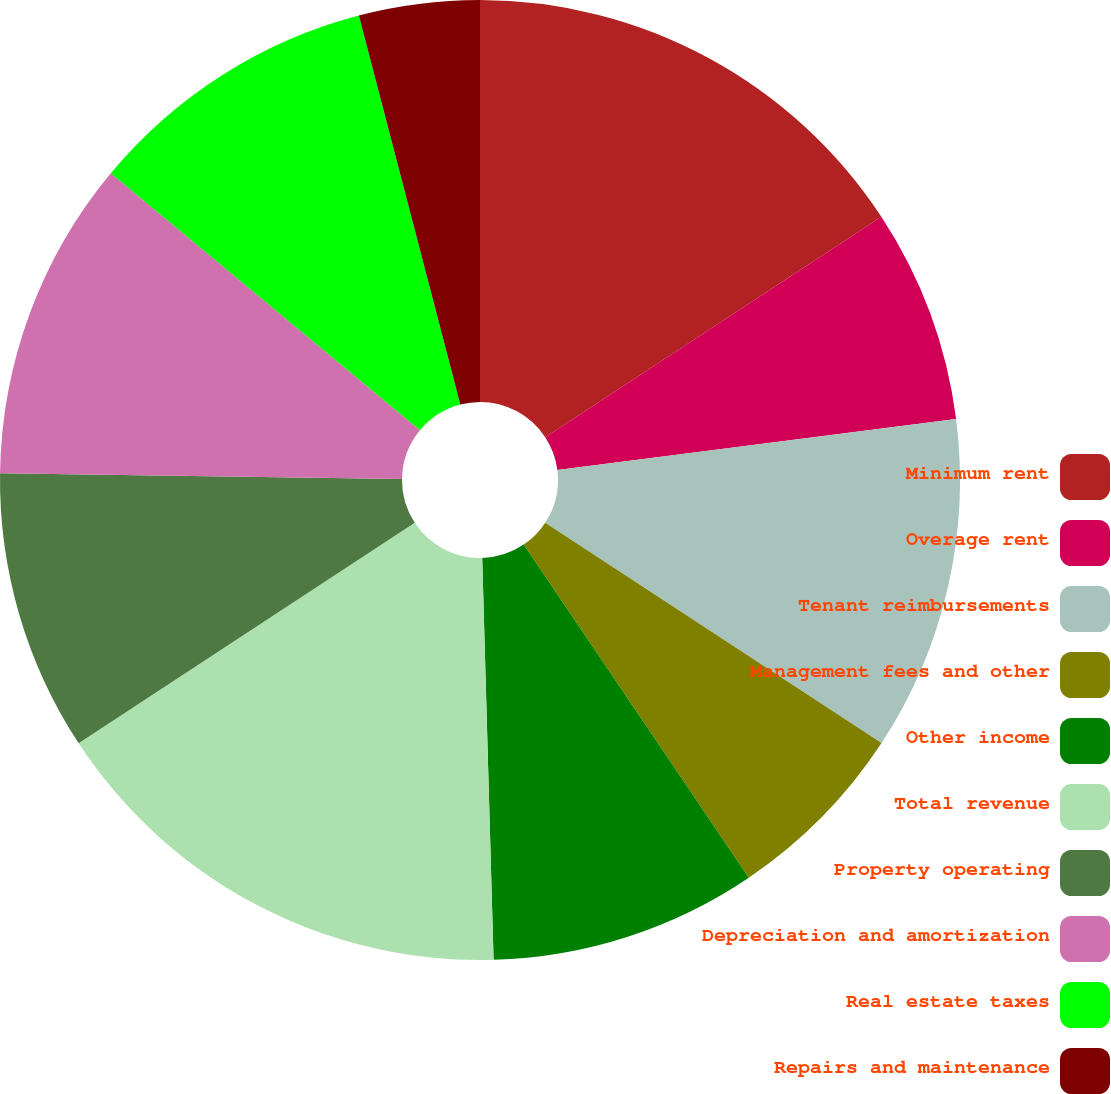<chart> <loc_0><loc_0><loc_500><loc_500><pie_chart><fcel>Minimum rent<fcel>Overage rent<fcel>Tenant reimbursements<fcel>Management fees and other<fcel>Other income<fcel>Total revenue<fcel>Property operating<fcel>Depreciation and amortization<fcel>Real estate taxes<fcel>Repairs and maintenance<nl><fcel>15.76%<fcel>7.21%<fcel>11.26%<fcel>6.31%<fcel>9.01%<fcel>16.21%<fcel>9.46%<fcel>10.81%<fcel>9.91%<fcel>4.06%<nl></chart> 